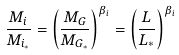Convert formula to latex. <formula><loc_0><loc_0><loc_500><loc_500>\frac { M _ { i } } { M _ { i _ { * } } } = \left ( \frac { M _ { G } } { M _ { G _ { * } } } \right ) ^ { \beta _ { i } } = \left ( \frac { L } { L _ { * } } \right ) ^ { \beta _ { i } }</formula> 